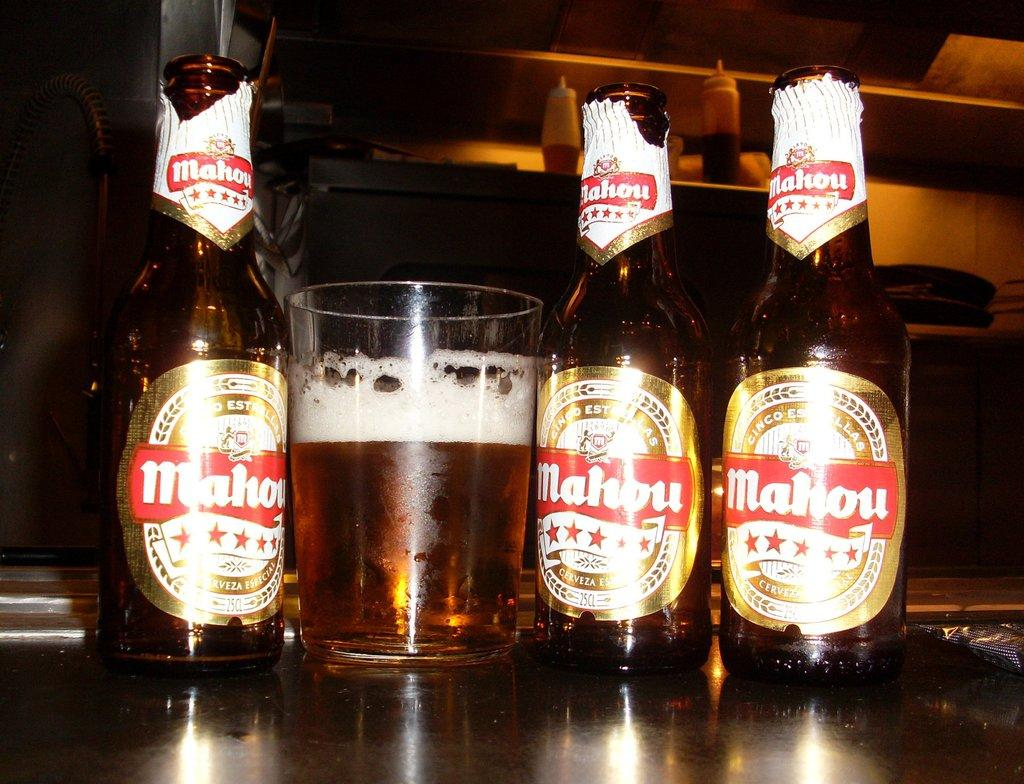Provide a one-sentence caption for the provided image. Three Mahou beer bottles and one glass likely filled with mahou beer as well. 